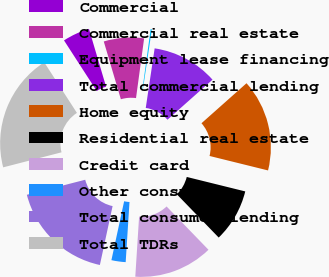Convert chart. <chart><loc_0><loc_0><loc_500><loc_500><pie_chart><fcel>Commercial<fcel>Commercial real estate<fcel>Equipment lease financing<fcel>Total commercial lending<fcel>Home equity<fcel>Residential real estate<fcel>Credit card<fcel>Other consumer<fcel>Total consumer lending<fcel>Total TDRs<nl><fcel>4.55%<fcel>6.73%<fcel>0.21%<fcel>11.08%<fcel>15.42%<fcel>8.9%<fcel>13.25%<fcel>2.38%<fcel>17.6%<fcel>19.88%<nl></chart> 